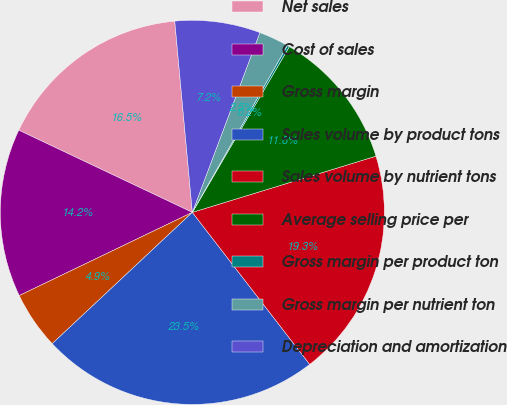Convert chart. <chart><loc_0><loc_0><loc_500><loc_500><pie_chart><fcel>Net sales<fcel>Cost of sales<fcel>Gross margin<fcel>Sales volume by product tons<fcel>Sales volume by nutrient tons<fcel>Average selling price per<fcel>Gross margin per product ton<fcel>Gross margin per nutrient ton<fcel>Depreciation and amortization<nl><fcel>16.5%<fcel>14.17%<fcel>4.85%<fcel>23.48%<fcel>19.26%<fcel>11.84%<fcel>0.19%<fcel>2.52%<fcel>7.18%<nl></chart> 